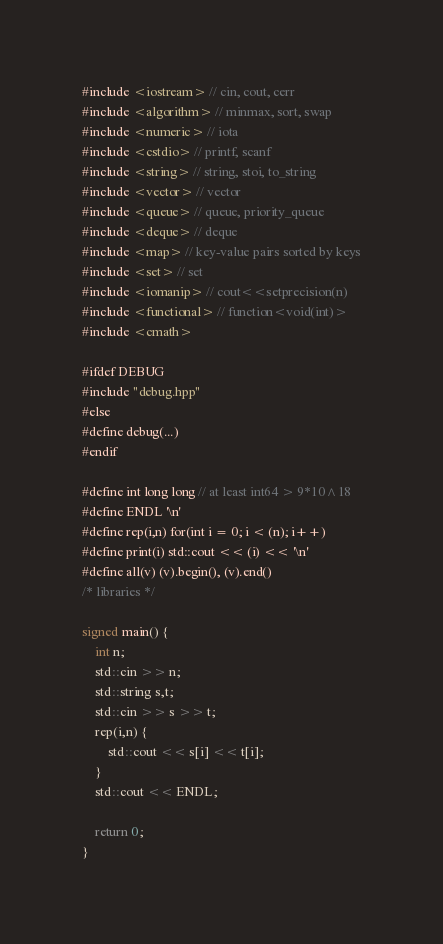Convert code to text. <code><loc_0><loc_0><loc_500><loc_500><_C++_>#include <iostream> // cin, cout, cerr
#include <algorithm> // minmax, sort, swap
#include <numeric> // iota
#include <cstdio> // printf, scanf
#include <string> // string, stoi, to_string
#include <vector> // vector
#include <queue> // queue, priority_queue
#include <deque> // deque
#include <map> // key-value pairs sorted by keys
#include <set> // set
#include <iomanip> // cout<<setprecision(n)
#include <functional> // function<void(int)>
#include <cmath>

#ifdef DEBUG
#include "debug.hpp"
#else
#define debug(...)
#endif

#define int long long // at least int64 > 9*10^18
#define ENDL '\n'
#define rep(i,n) for(int i = 0; i < (n); i++)
#define print(i) std::cout << (i) << '\n'
#define all(v) (v).begin(), (v).end()
/* libraries */

signed main() {
	int n;
	std::cin >> n;
	std::string s,t;
	std::cin >> s >> t;
	rep(i,n) {
		std::cout << s[i] << t[i];
	}
	std::cout << ENDL;

	return 0;
}
</code> 